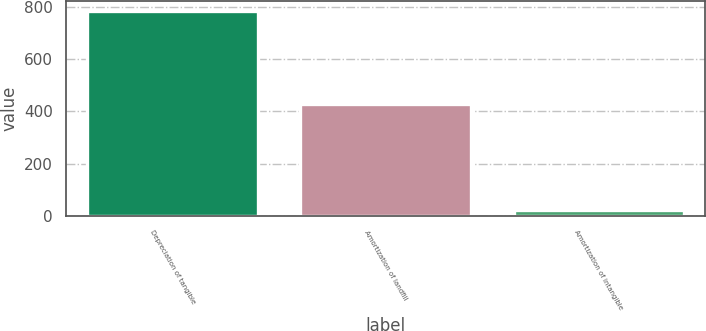<chart> <loc_0><loc_0><loc_500><loc_500><bar_chart><fcel>Depreciation of tangible<fcel>Amortization of landfill<fcel>Amortization of intangible<nl><fcel>785<fcel>429<fcel>24<nl></chart> 